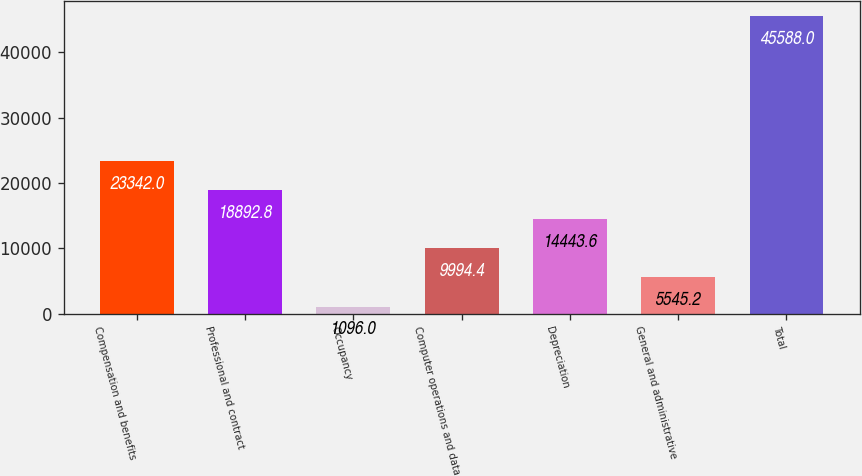Convert chart to OTSL. <chart><loc_0><loc_0><loc_500><loc_500><bar_chart><fcel>Compensation and benefits<fcel>Professional and contract<fcel>Occupancy<fcel>Computer operations and data<fcel>Depreciation<fcel>General and administrative<fcel>Total<nl><fcel>23342<fcel>18892.8<fcel>1096<fcel>9994.4<fcel>14443.6<fcel>5545.2<fcel>45588<nl></chart> 